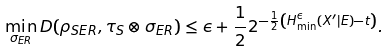Convert formula to latex. <formula><loc_0><loc_0><loc_500><loc_500>\min _ { \sigma _ { E R } } D ( \rho _ { S E R } , \tau _ { S } \otimes \sigma _ { E R } ) \leq \epsilon + \frac { 1 } { 2 } 2 ^ { - \frac { 1 } { 2 } \left ( H _ { \min } ^ { \epsilon } ( X ^ { \prime } | E ) - t \right ) } .</formula> 